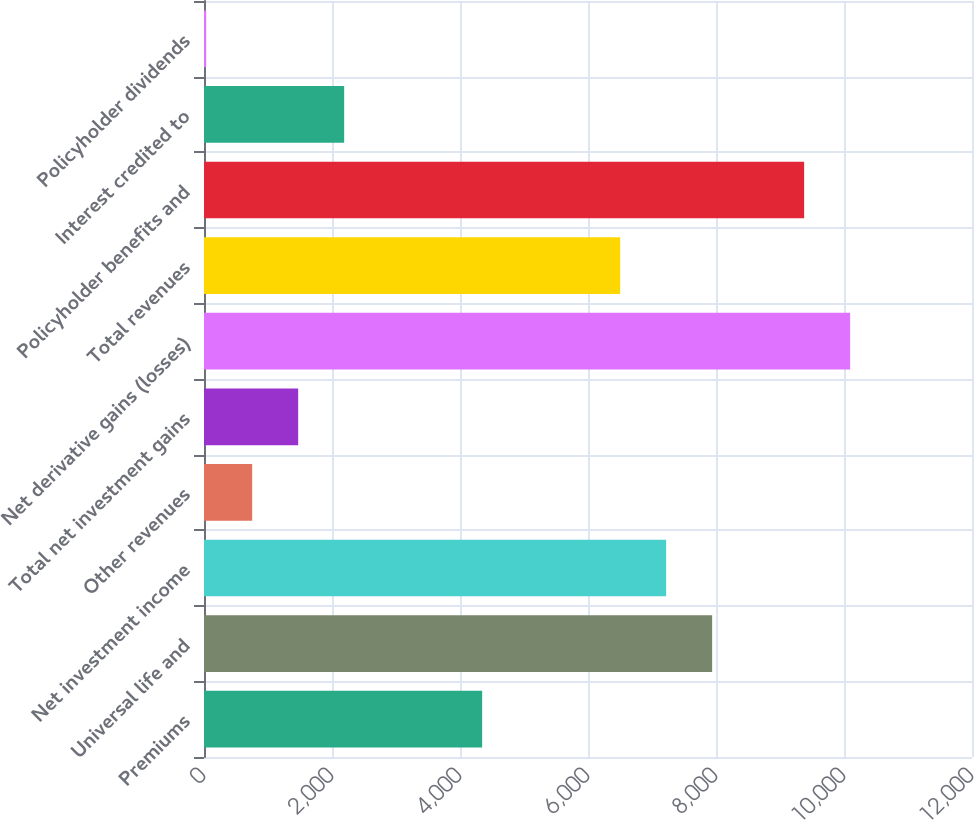Convert chart. <chart><loc_0><loc_0><loc_500><loc_500><bar_chart><fcel>Premiums<fcel>Universal life and<fcel>Net investment income<fcel>Other revenues<fcel>Total net investment gains<fcel>Net derivative gains (losses)<fcel>Total revenues<fcel>Policyholder benefits and<fcel>Interest credited to<fcel>Policyholder dividends<nl><fcel>4346.2<fcel>7939.7<fcel>7221<fcel>752.7<fcel>1471.4<fcel>10095.8<fcel>6502.3<fcel>9377.1<fcel>2190.1<fcel>34<nl></chart> 